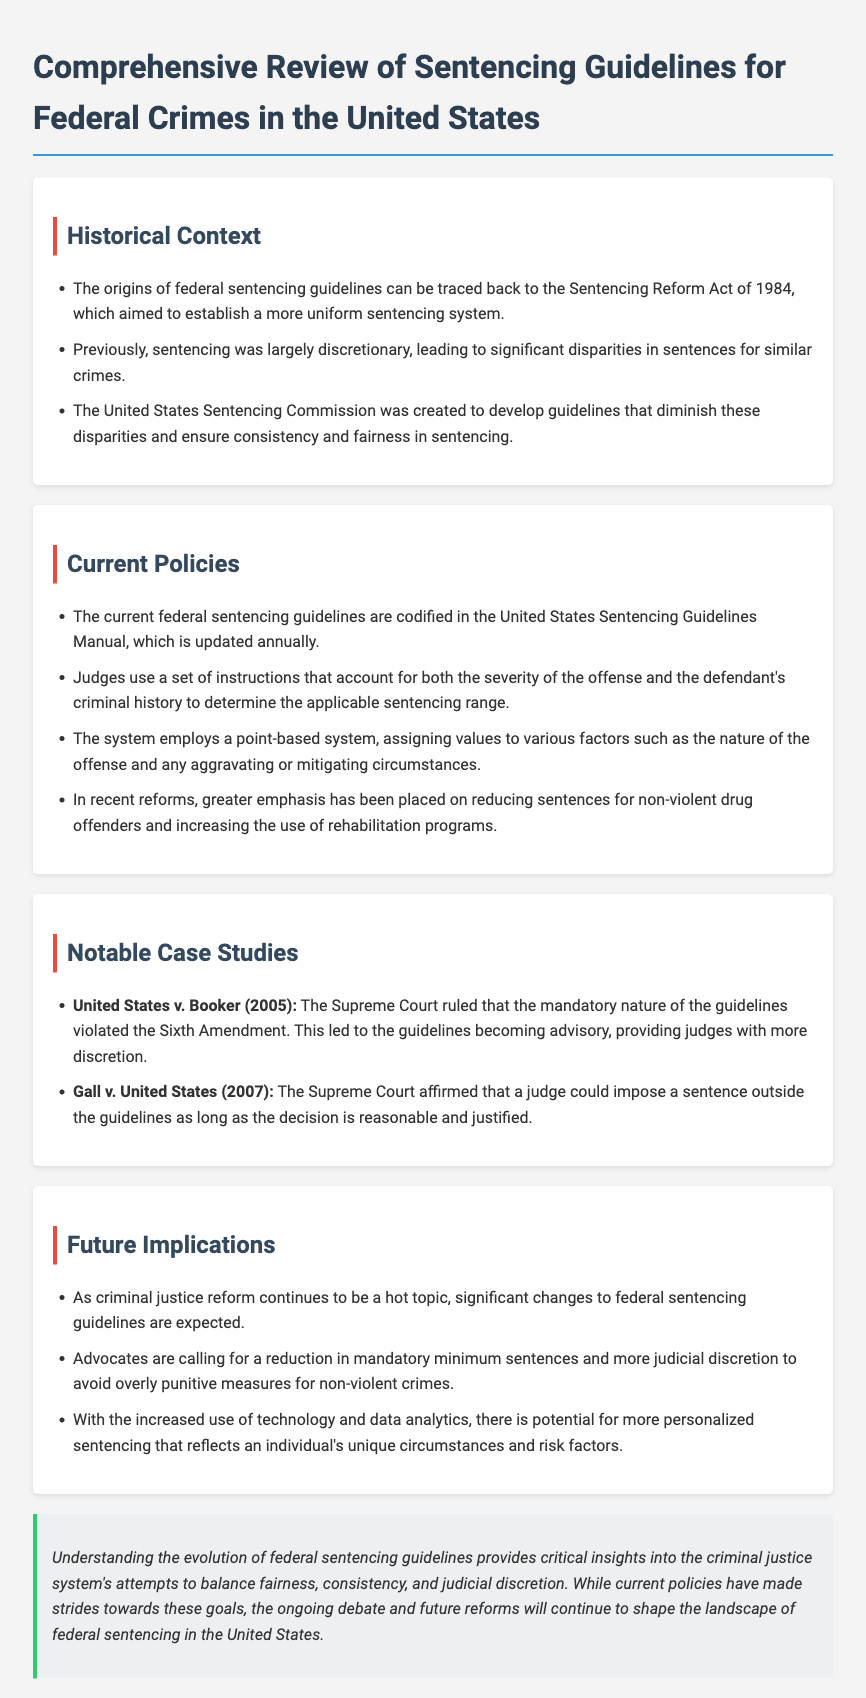what year did the Sentencing Reform Act take place? The year when the Sentencing Reform Act was enacted is mentioned as 1984 in the document.
Answer: 1984 what is the purpose of the United States Sentencing Commission? The document states that the United States Sentencing Commission was created to develop guidelines that diminish disparities and ensure consistency and fairness in sentencing.
Answer: consistency and fairness what notable case ruled that the mandatory nature of guidelines violated the Sixth Amendment? The document refers to United States v. Booker (2005) as the case that ruled the mandatory nature of the guidelines violated the Sixth Amendment.
Answer: United States v. Booker what is the current format of federal sentencing guidelines? The document indicates that the current federal sentencing guidelines are codified in the United States Sentencing Guidelines Manual, which is updated annually.
Answer: United States Sentencing Guidelines Manual what has recent reforms emphasized for non-violent offenders? According to the document, recent reforms have placed greater emphasis on reducing sentences for non-violent drug offenders and increasing the use of rehabilitation programs.
Answer: rehabilitation programs how has the Supreme Court's ruling in Gall v. United States (2007) affected judicial discretion? The document mentions that the ruling in Gall v. United States affirmed that a judge could impose a sentence outside the guidelines as long as the decision is reasonable and justified.
Answer: reasonable and justified what change do advocates seek regarding mandatory minimum sentences? The document states that advocates are calling for a reduction in mandatory minimum sentences.
Answer: reduction what is one potential advancement in sentencing mentioned for the future? The document indicates that there is potential for more personalized sentencing utilizing technology and data analytics.
Answer: personalized sentencing 